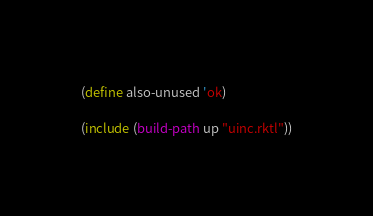Convert code to text. <code><loc_0><loc_0><loc_500><loc_500><_Racket_>
(define also-unused 'ok)

(include (build-path up "uinc.rktl"))

</code> 